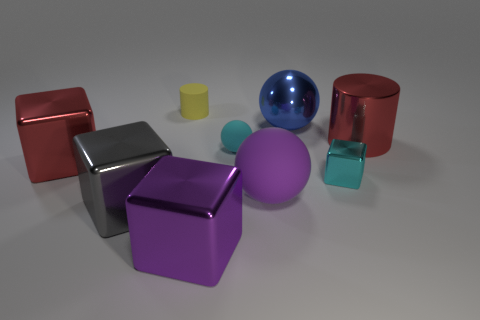Is the size of the gray shiny object the same as the cyan thing that is on the right side of the big blue metallic sphere?
Ensure brevity in your answer.  No. What number of tiny things are green metallic balls or purple things?
Provide a short and direct response. 0. Are there more big metallic things than large blue rubber spheres?
Your answer should be compact. Yes. There is a big red metal thing that is to the left of the big purple thing on the left side of the cyan rubber thing; what number of cyan things are left of it?
Offer a very short reply. 0. The cyan metallic thing has what shape?
Provide a short and direct response. Cube. How many other things are made of the same material as the purple ball?
Your answer should be compact. 2. Is the size of the yellow cylinder the same as the cyan rubber ball?
Give a very brief answer. Yes. There is a tiny thing that is behind the small matte ball; what shape is it?
Ensure brevity in your answer.  Cylinder. What color is the rubber cylinder behind the large cube right of the gray metallic block?
Provide a short and direct response. Yellow. There is a red metal object on the left side of the big purple rubber sphere; is it the same shape as the small matte object that is behind the cyan sphere?
Ensure brevity in your answer.  No. 